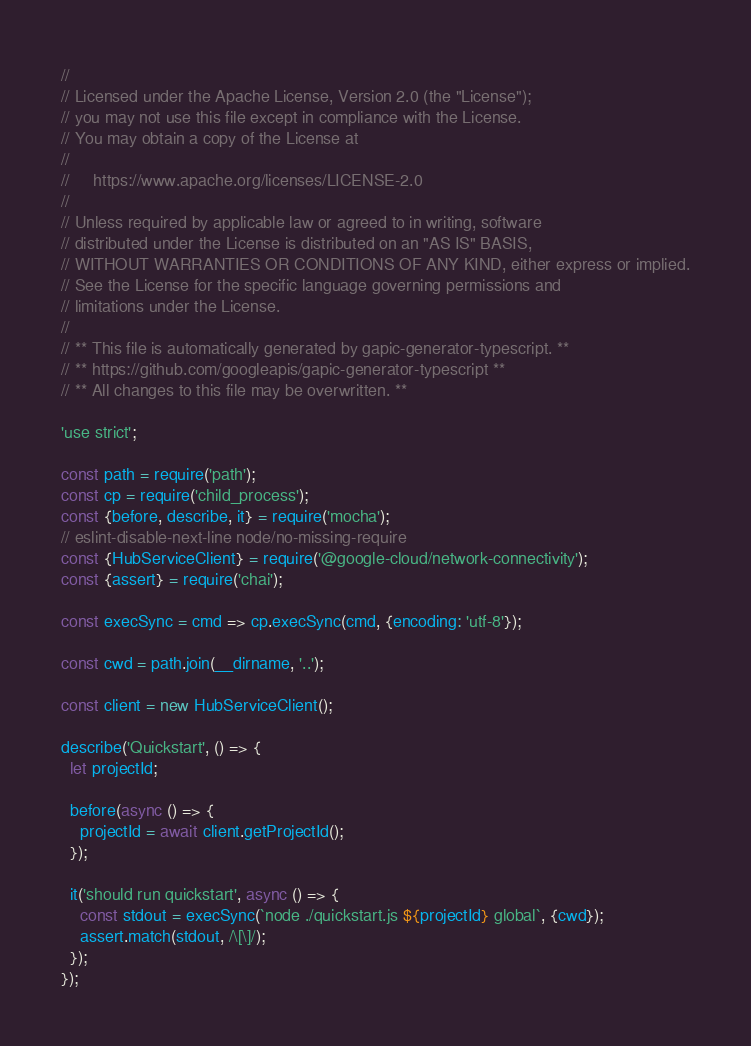<code> <loc_0><loc_0><loc_500><loc_500><_JavaScript_>//
// Licensed under the Apache License, Version 2.0 (the "License");
// you may not use this file except in compliance with the License.
// You may obtain a copy of the License at
//
//     https://www.apache.org/licenses/LICENSE-2.0
//
// Unless required by applicable law or agreed to in writing, software
// distributed under the License is distributed on an "AS IS" BASIS,
// WITHOUT WARRANTIES OR CONDITIONS OF ANY KIND, either express or implied.
// See the License for the specific language governing permissions and
// limitations under the License.
//
// ** This file is automatically generated by gapic-generator-typescript. **
// ** https://github.com/googleapis/gapic-generator-typescript **
// ** All changes to this file may be overwritten. **

'use strict';

const path = require('path');
const cp = require('child_process');
const {before, describe, it} = require('mocha');
// eslint-disable-next-line node/no-missing-require
const {HubServiceClient} = require('@google-cloud/network-connectivity');
const {assert} = require('chai');

const execSync = cmd => cp.execSync(cmd, {encoding: 'utf-8'});

const cwd = path.join(__dirname, '..');

const client = new HubServiceClient();

describe('Quickstart', () => {
  let projectId;

  before(async () => {
    projectId = await client.getProjectId();
  });

  it('should run quickstart', async () => {
    const stdout = execSync(`node ./quickstart.js ${projectId} global`, {cwd});
    assert.match(stdout, /\[\]/);
  });
});
</code> 